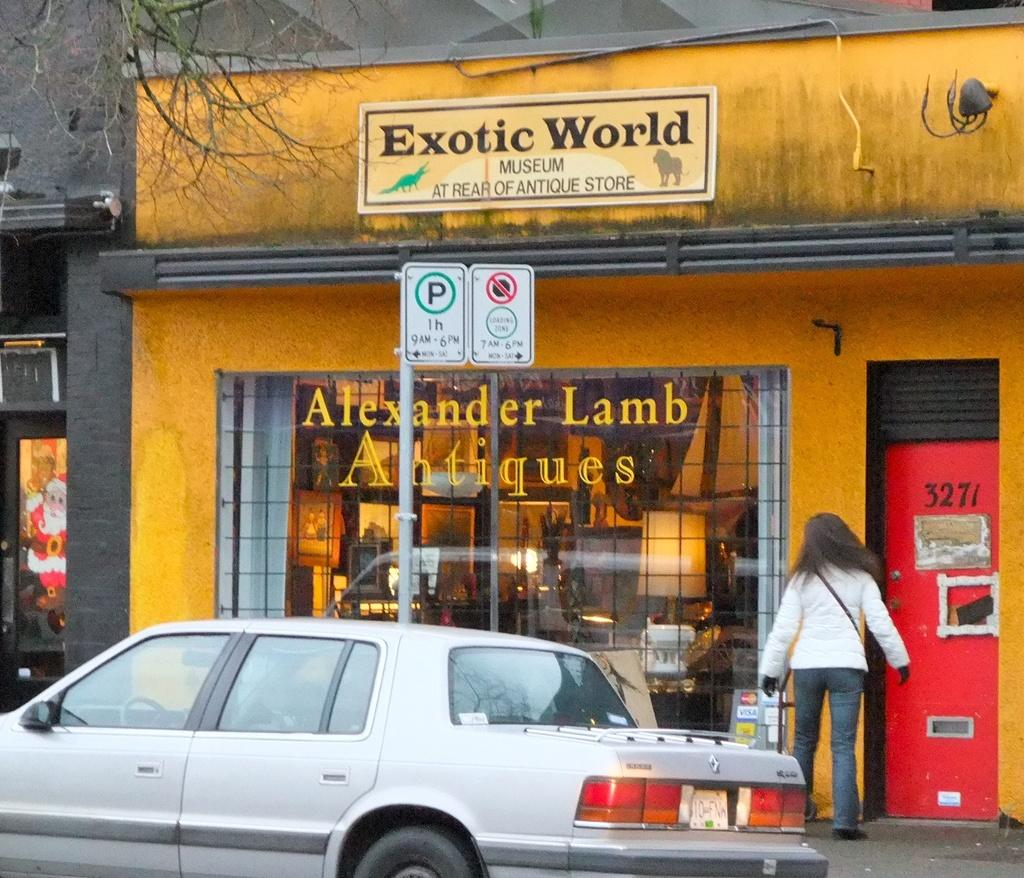Who is present in the image? There is a woman in the image. What is in front of the store in the image? There is a car in front of a store in the image. What can be seen on the store or nearby structures? There are sign boards and a hoarding in the image. What type of material is visible in the image? Metal rods are visible in the image. What type of vegetation is present in the image? There is a tree in the image. What type of zinc is being used to construct the tree in the image? There is no zinc being used to construct the tree in the image; it is a natural tree. What color is the coat worn by the woman in the image? There is no information about the woman's coat in the image, as the facts provided do not mention clothing. 